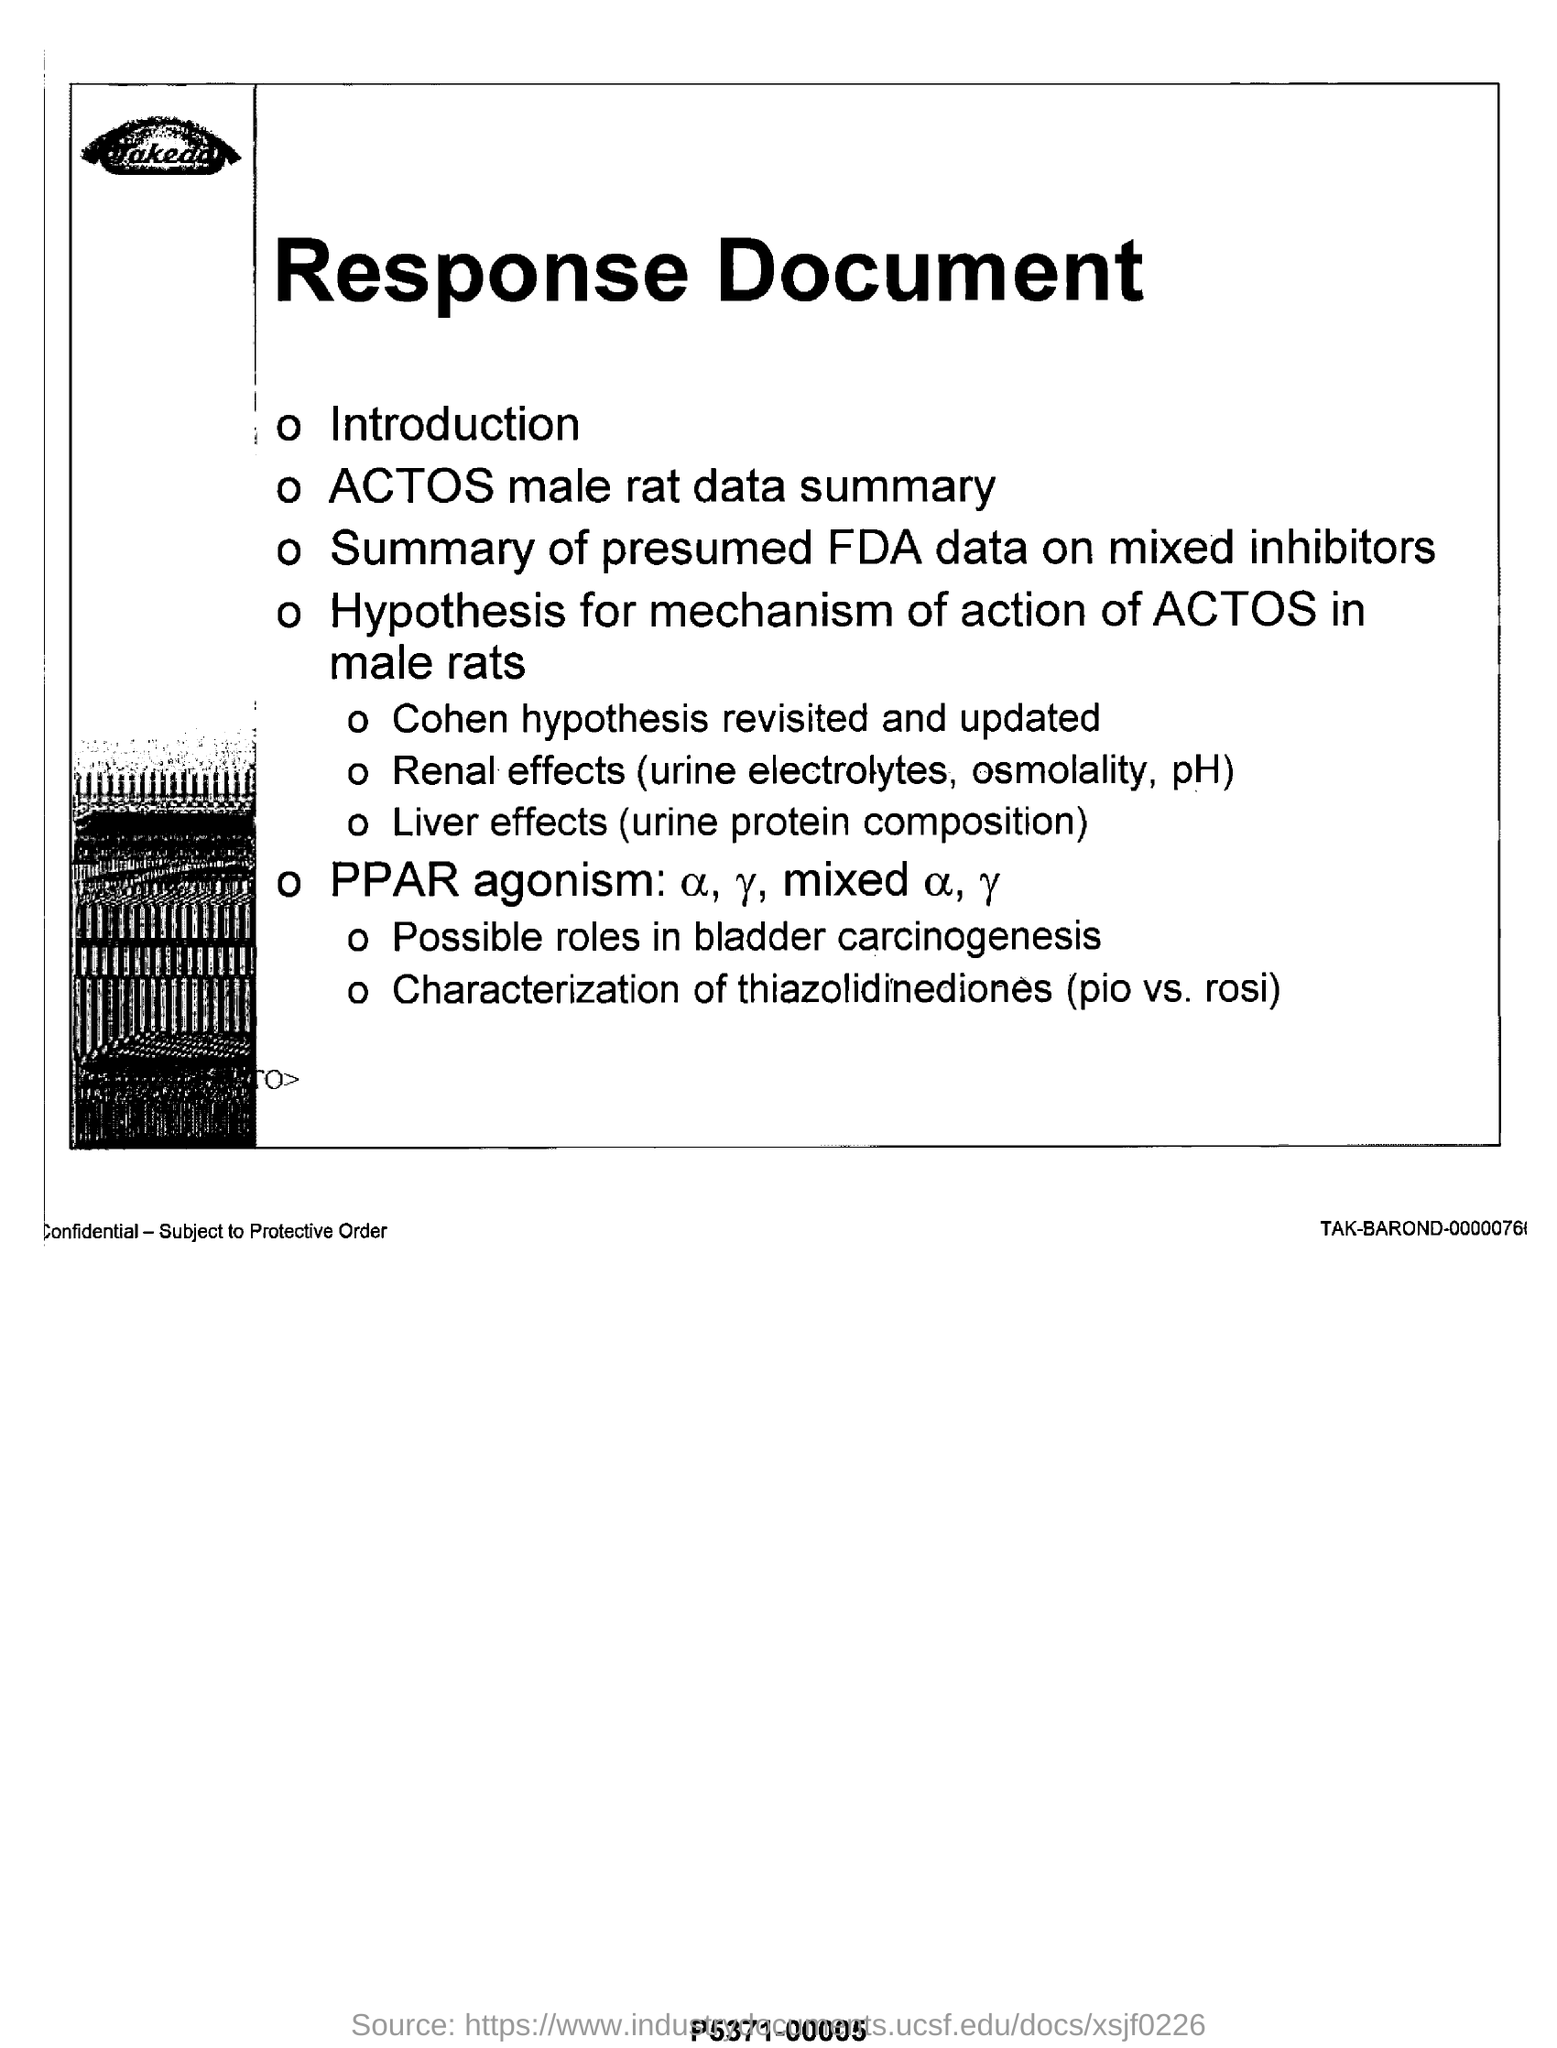What is the heading of the document?
Keep it short and to the point. Response Document. What are mixed with α, γ?
Keep it short and to the point. Α, γ. What are the renal effects mentioned?
Provide a succinct answer. Urine electrolytes, osmolality, ph. 